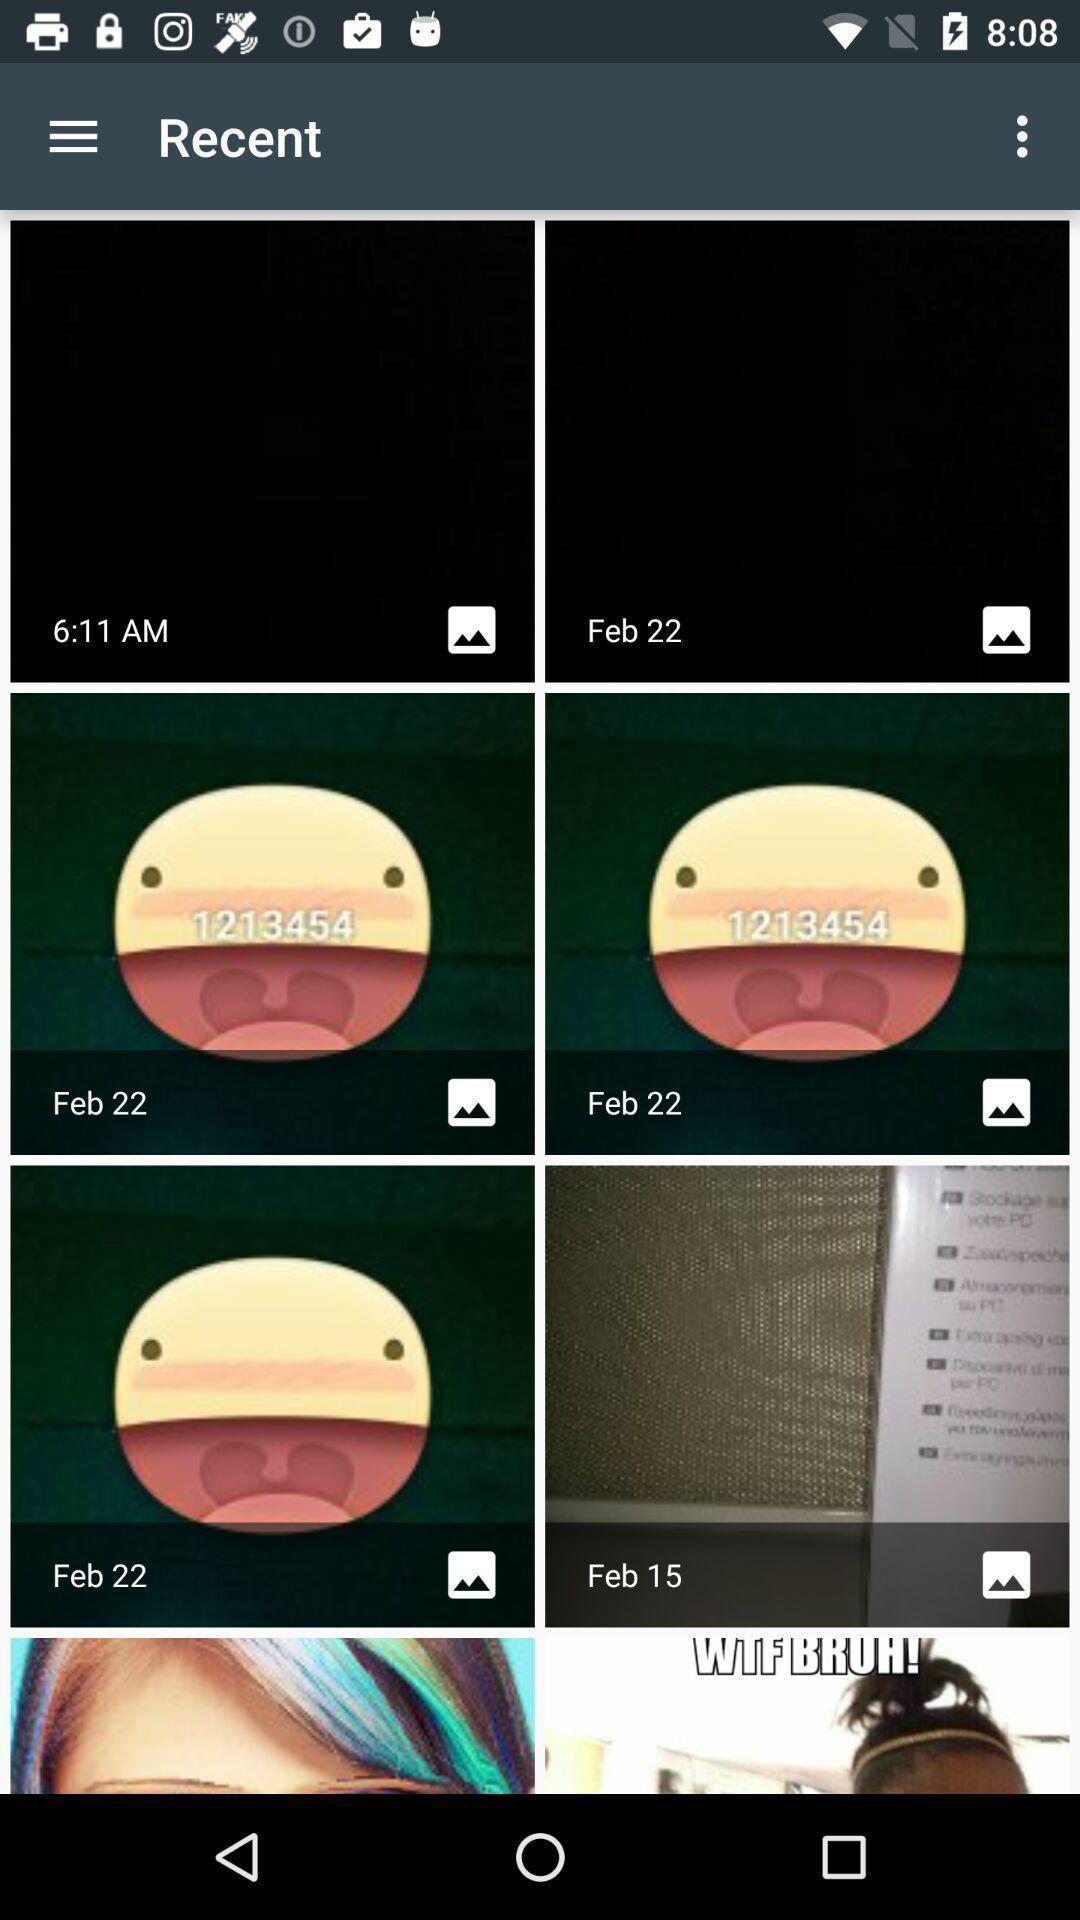Give me a summary of this screen capture. Page showing recent pictures in the gallery app. 